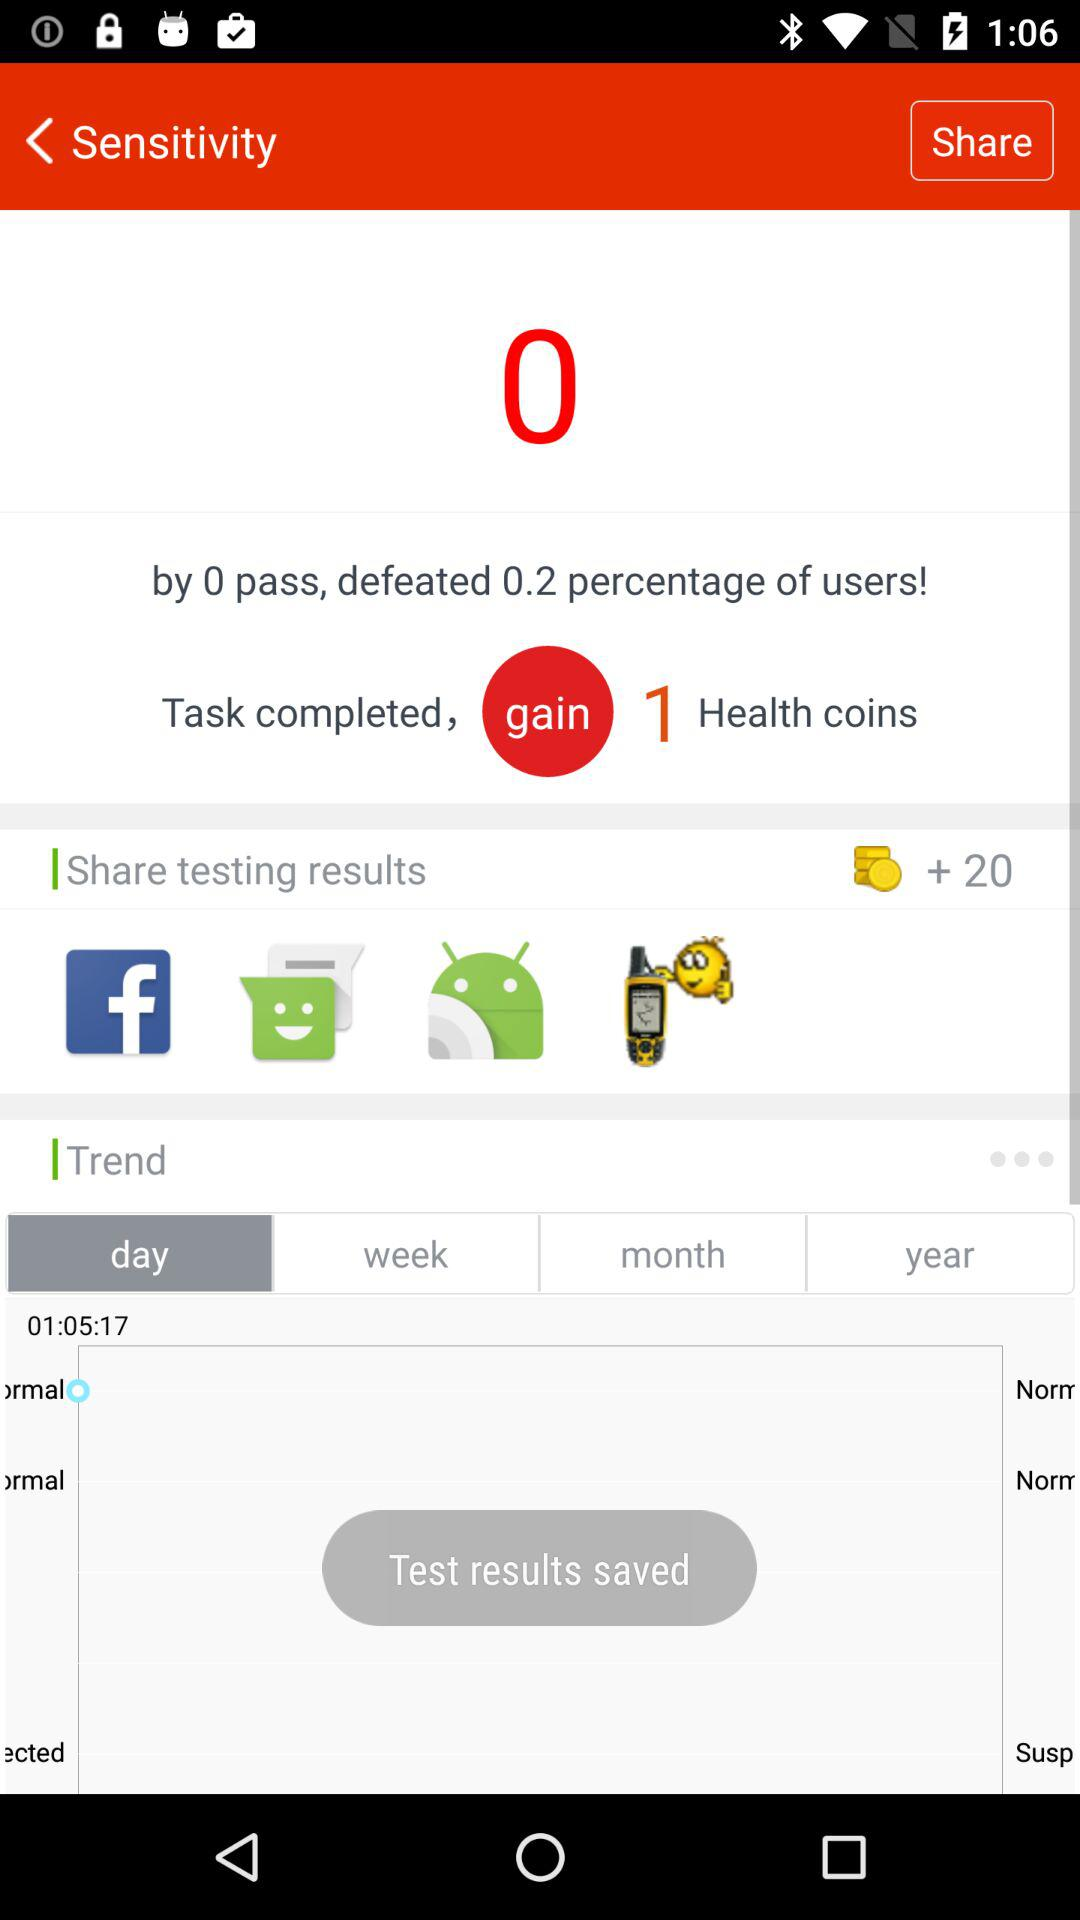How many health coins are to be gained on completion of the task? There is 1 health coin to be gained. 